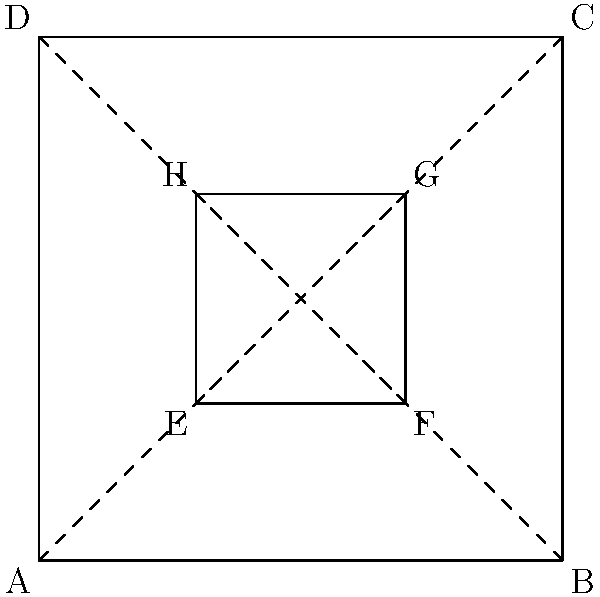In the diagram above, ABCD represents a room, and EFGH represents a furniture arrangement. If we apply projective geometry principles to create a perspective-defying illusion, which line segment would be most effective in creating a visual distortion when viewed from point A? To answer this question, we need to consider the principles of projective geometry and how they can be applied to create perspective-defying illusions in interior design:

1. Projective geometry deals with properties of geometric figures that remain invariant under projections.

2. In this context, we're looking for a line segment that, when viewed from point A, could create the most significant visual distortion.

3. The key is to consider how the perception of the line segment changes based on the viewer's position at point A.

4. Line segments that are parallel to the viewer's line of sight (from point A) will appear to converge at a vanishing point, creating a strong sense of depth and perspective.

5. Among the given line segments, EG and FH are diagonal lines within the furniture arrangement.

6. The line segment FH is more aligned with the viewer's line of sight from point A, as it's closer to being parallel with the diagonal AC.

7. When viewed from point A, FH would appear to converge more dramatically towards the vanishing point (near point C), creating a stronger illusion of depth and distortion.

8. This effect can be used to create a perspective-defying illusion, making the furniture arrangement appear larger or more dynamic than it actually is.

Therefore, line segment FH would be most effective in creating a visual distortion when viewed from point A.
Answer: FH 